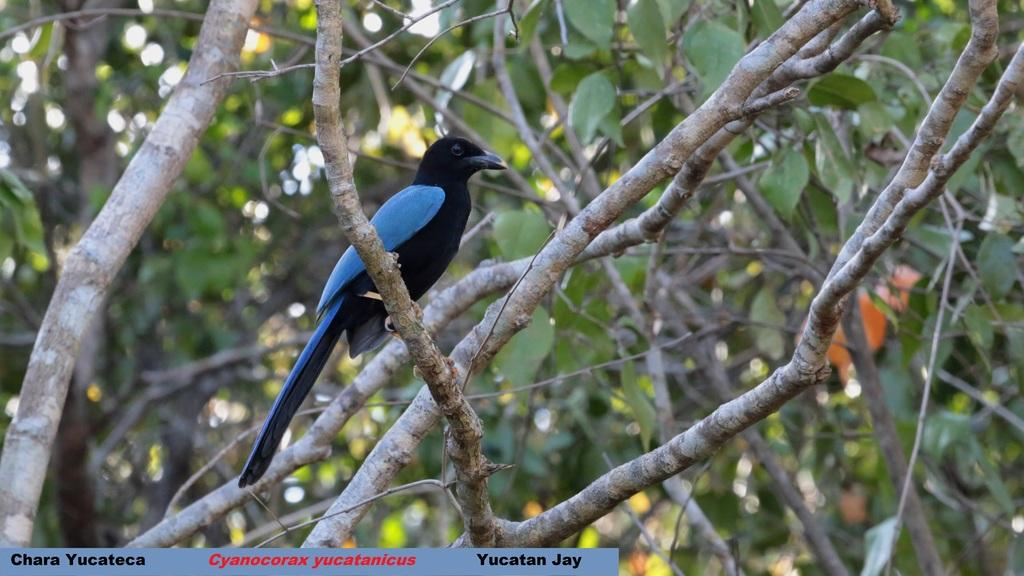What type of animal is in the image? There is a bird in the image. Can you describe the bird's color? The bird is black and blue in color. What is the bird standing on? The bird is standing on stems. What can be seen in the background of the image? There are leaves and stems visible in the background of the image, but they are blurred. How many sheep are visible in the image? There are no sheep present in the image; it features a bird standing on stems. What type of grape is being used to cover the bird in the image? There is no grape present in the image, nor is the bird being covered by anything. 